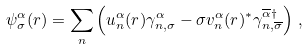Convert formula to latex. <formula><loc_0><loc_0><loc_500><loc_500>\psi _ { \sigma } ^ { \alpha } ( { r } ) = \sum _ { n } \left ( u _ { n } ^ { \alpha } ( { r } ) \gamma ^ { \alpha } _ { n , \sigma } - \sigma v _ { n } ^ { \alpha } ( { r } ) ^ { * } \gamma ^ { \overline { \alpha } \dagger } _ { n , \overline { \sigma } } \right ) \, ,</formula> 